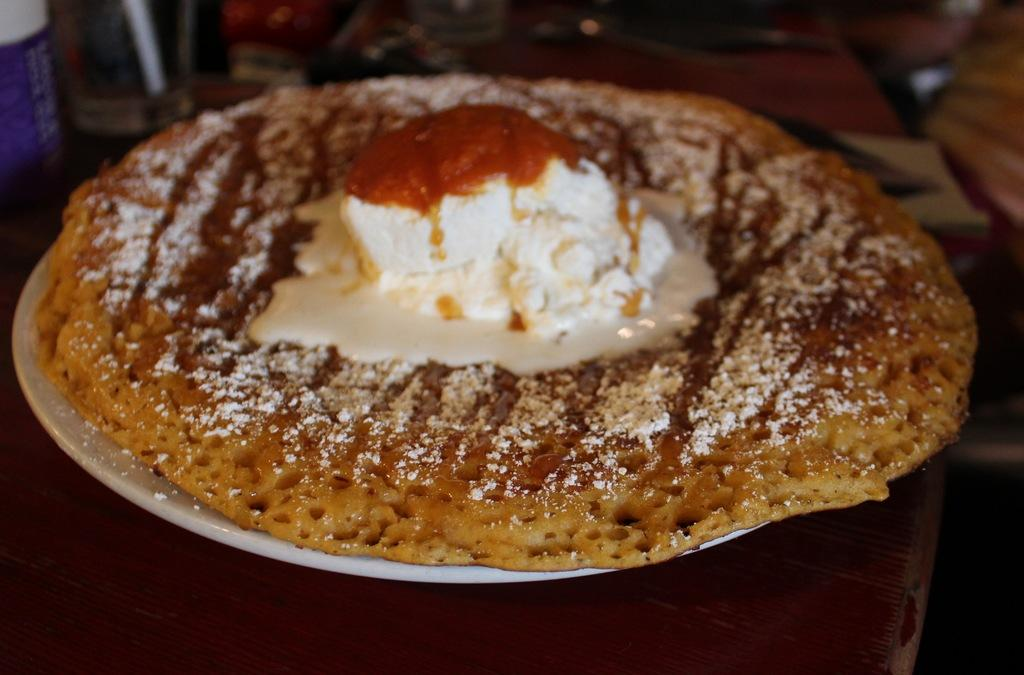What is on the plate that is visible in the image? There is a food item on a plate in the image. Where is the plate located in the image? The plate is placed on a table in the image. What else can be seen on the table in the image? There are other objects on the table in the image. How many beds are visible in the image? There are no beds visible in the image; it features a plate with a food item on a table. Is there a frame around the food item in the image? There is no frame around the food item in the image; it is simply placed on a plate. 